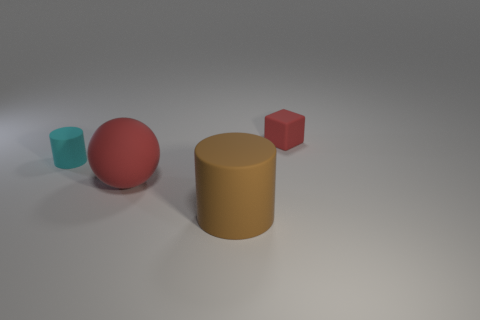Add 2 big objects. How many objects exist? 6 Subtract all balls. How many objects are left? 3 Add 4 small rubber cylinders. How many small rubber cylinders exist? 5 Subtract 0 blue balls. How many objects are left? 4 Subtract all small red things. Subtract all cyan matte cylinders. How many objects are left? 2 Add 1 small cubes. How many small cubes are left? 2 